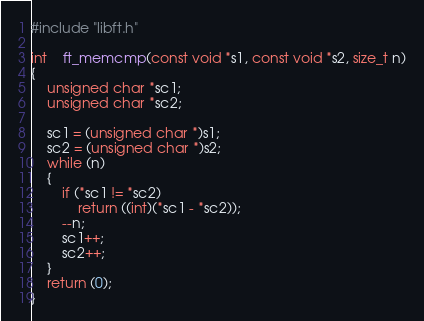<code> <loc_0><loc_0><loc_500><loc_500><_C_>
#include "libft.h"

int	ft_memcmp(const void *s1, const void *s2, size_t n)
{
	unsigned char *sc1;
	unsigned char *sc2;

	sc1 = (unsigned char *)s1;
	sc2 = (unsigned char *)s2;
	while (n)
	{
		if (*sc1 != *sc2)
			return ((int)(*sc1 - *sc2));
		--n;
		sc1++;
		sc2++;
	}
	return (0);
}
</code> 